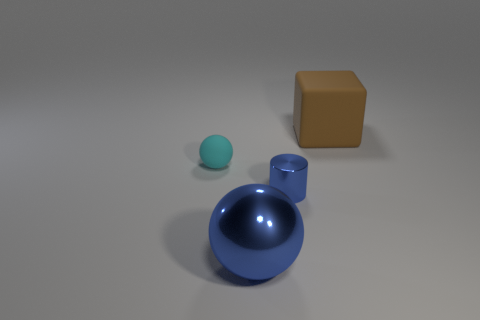The metallic ball is what size?
Ensure brevity in your answer.  Large. There is a rubber thing to the left of the small metal cylinder; what size is it?
Make the answer very short. Small. There is a brown rubber object that is behind the metallic ball; is its size the same as the big blue metal sphere?
Offer a very short reply. Yes. Is there any other thing that is the same color as the cube?
Keep it short and to the point. No. The tiny rubber thing is what shape?
Your answer should be compact. Sphere. What number of objects are both right of the cyan matte sphere and in front of the brown rubber object?
Offer a very short reply. 2. Is the color of the tiny cylinder the same as the matte ball?
Provide a succinct answer. No. There is a big object that is the same shape as the tiny matte thing; what material is it?
Give a very brief answer. Metal. Are there the same number of large brown rubber cubes to the right of the large block and tiny rubber objects left of the small cylinder?
Provide a short and direct response. No. Do the blue sphere and the cyan object have the same material?
Offer a terse response. No. 